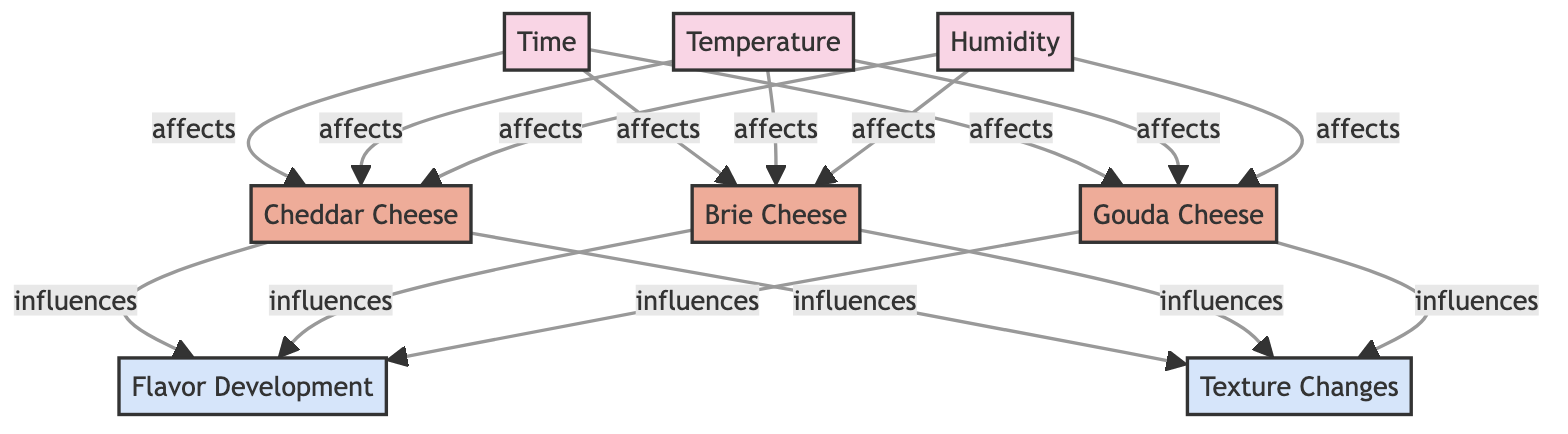What are the nodes present in the diagram? The nodes in the diagram are Time, Temperature, Humidity, Cheddar Cheese, Brie Cheese, Gouda Cheese, Flavor Development, and Texture Changes.
Answer: Time, Temperature, Humidity, Cheddar Cheese, Brie Cheese, Gouda Cheese, Flavor Development, Texture Changes How many types of cheese are represented in the diagram? There are three types of cheese represented: Cheddar, Brie, and Gouda.
Answer: Three Which factor affects Cheddar Cheese? The factors affecting Cheddar Cheese are Time, Temperature, and Humidity.
Answer: Time, Temperature, Humidity What influences Flavor Development? The cheeses that influence Flavor Development are Cheddar Cheese, Brie Cheese, and Gouda Cheese.
Answer: Cheddar Cheese, Brie Cheese, Gouda Cheese What is the relationship between Temperature and Brie Cheese? The relationship is that Temperature affects Brie Cheese, indicating a direct influence on its aging process.
Answer: Affects If Time increases, how does it affect Gouda Cheese? An increase in Time affects Gouda Cheese, likely contributing to its aging and flavor development.
Answer: Affects What outcomes are influenced by Cheddar Cheese? Cheddar Cheese influences Flavor Development and Texture Changes, indicating its role in both taste and physical characteristics.
Answer: Flavor Development, Texture Changes How many edges connect the factor nodes to the cheese nodes? Each factor (Time, Temperature, Humidity) connects to each cheese (Cheddar, Brie, Gouda), resulting in a total of nine edges.
Answer: Nine Which variable has the most connections to cheese types? The factors of Time, Temperature, and Humidity each connect to all three cheese types, implying equal influence across all.
Answer: Equal influence across all 